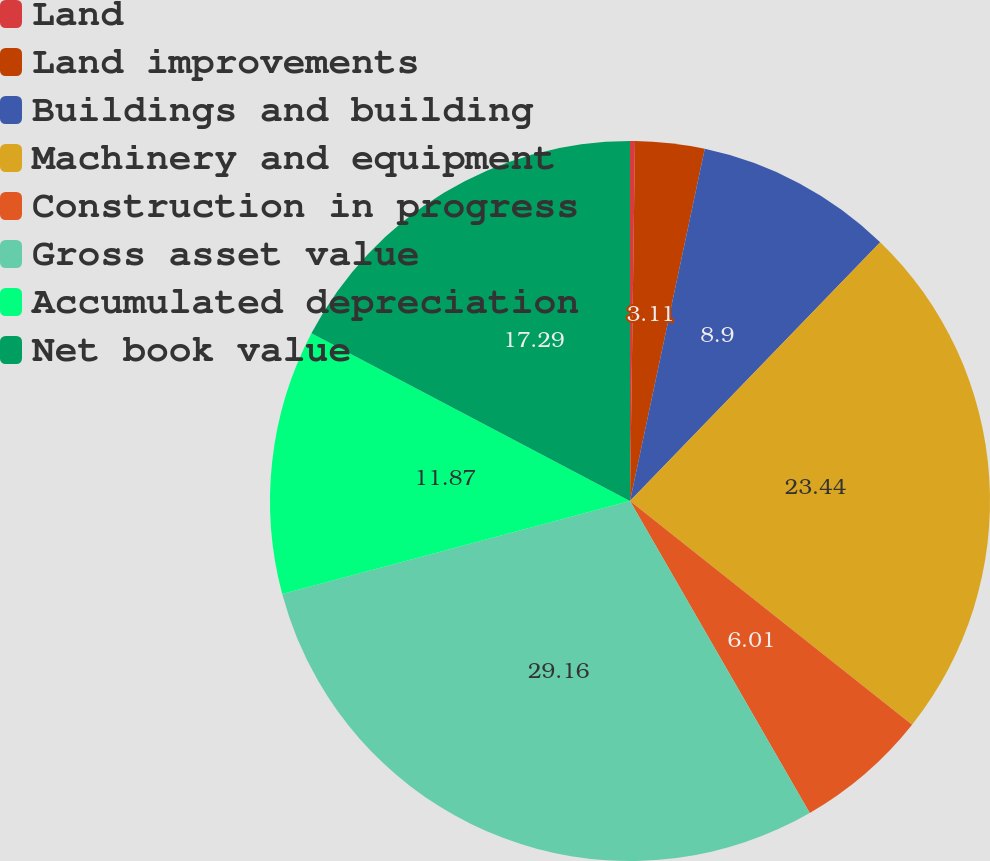Convert chart to OTSL. <chart><loc_0><loc_0><loc_500><loc_500><pie_chart><fcel>Land<fcel>Land improvements<fcel>Buildings and building<fcel>Machinery and equipment<fcel>Construction in progress<fcel>Gross asset value<fcel>Accumulated depreciation<fcel>Net book value<nl><fcel>0.22%<fcel>3.11%<fcel>8.9%<fcel>23.44%<fcel>6.01%<fcel>29.16%<fcel>11.87%<fcel>17.29%<nl></chart> 